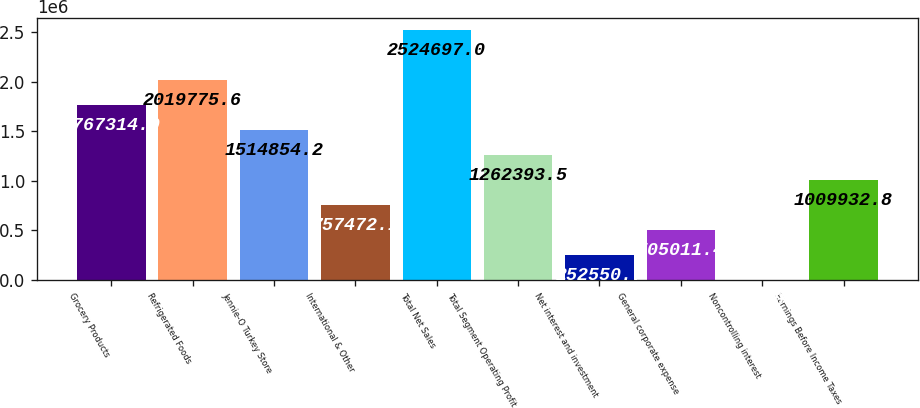Convert chart to OTSL. <chart><loc_0><loc_0><loc_500><loc_500><bar_chart><fcel>Grocery Products<fcel>Refrigerated Foods<fcel>Jennie-O Turkey Store<fcel>International & Other<fcel>Total Net Sales<fcel>Total Segment Operating Profit<fcel>Net interest and investment<fcel>General corporate expense<fcel>Noncontrolling interest<fcel>Earnings Before Income Taxes<nl><fcel>1.76731e+06<fcel>2.01978e+06<fcel>1.51485e+06<fcel>757472<fcel>2.5247e+06<fcel>1.26239e+06<fcel>252551<fcel>505011<fcel>90<fcel>1.00993e+06<nl></chart> 